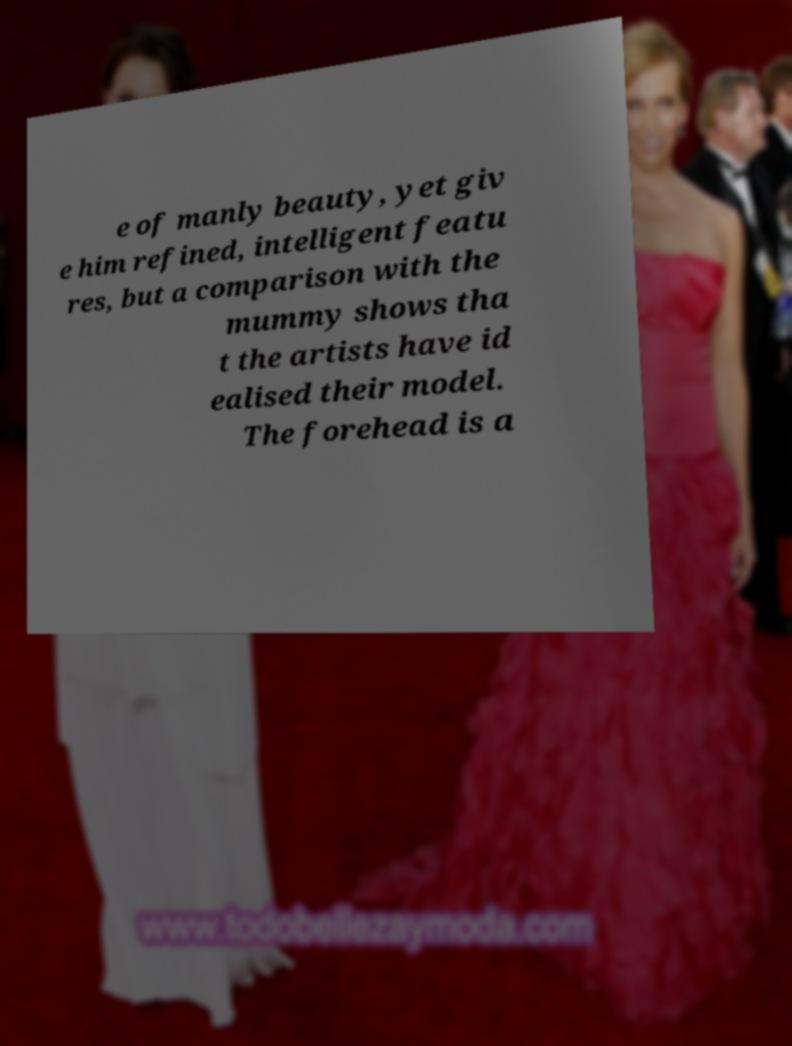For documentation purposes, I need the text within this image transcribed. Could you provide that? e of manly beauty, yet giv e him refined, intelligent featu res, but a comparison with the mummy shows tha t the artists have id ealised their model. The forehead is a 